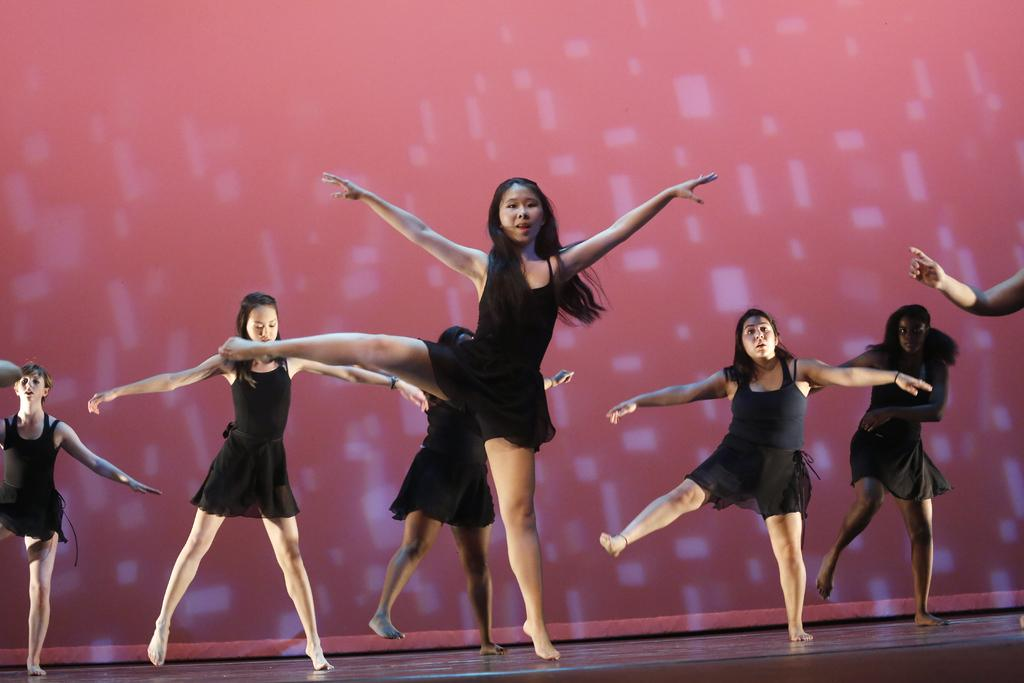What is happening in the image? There are women in the image, and they are dancing on a stage. What are the women wearing? The women are wearing black dresses. What can be seen in the background of the image? There is a wall visible in the background of the image. What type of pear is growing on the collar of one of the women in the image? There is no pear or collar present in the image; the women are wearing black dresses while dancing on a stage. 